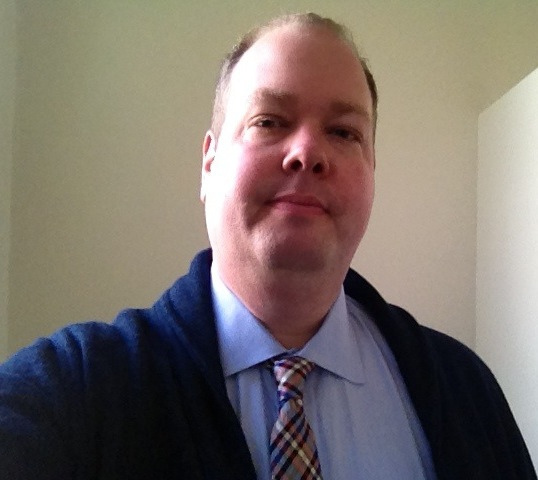<image>Where is he going? It is ambiguous where he is going. It could be work or home. Where is he going? I don't know where he is going. It can be work or home. 